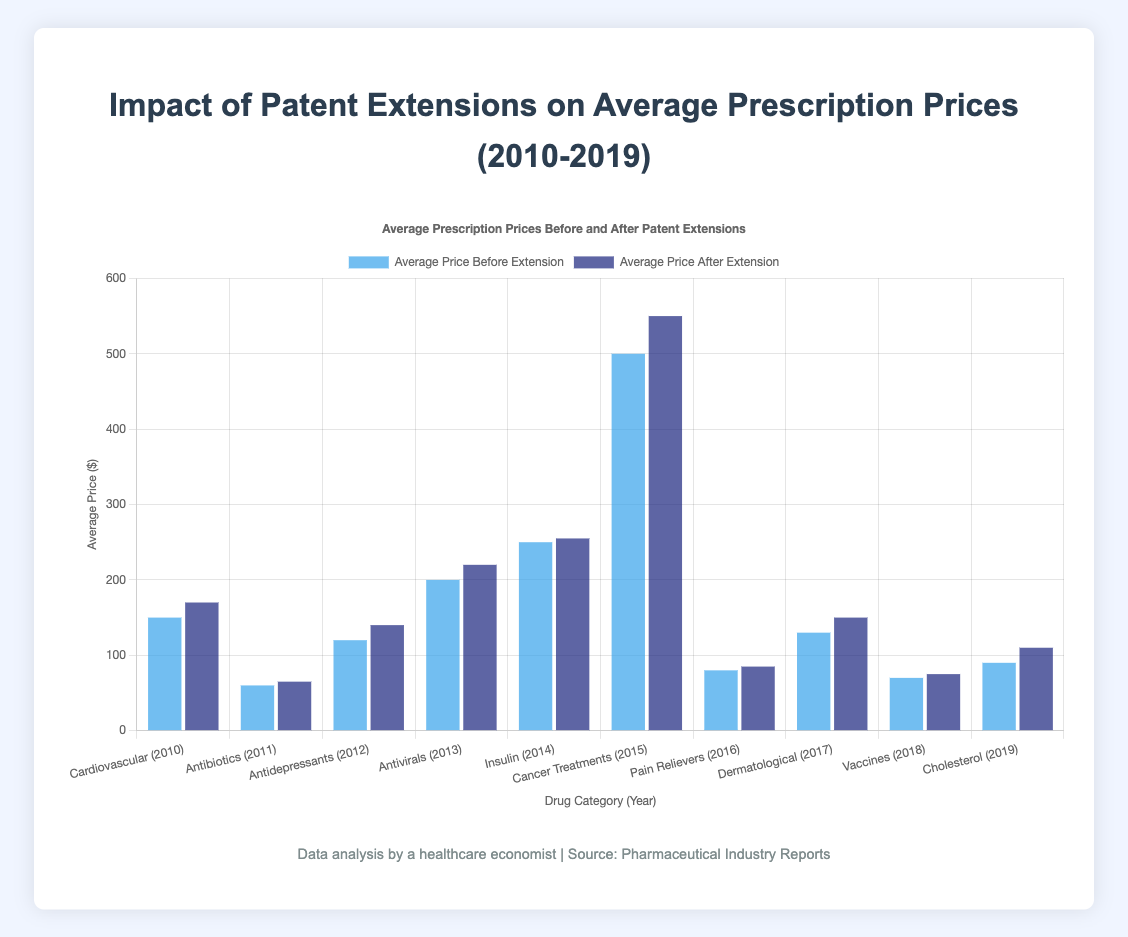What is the difference between the average price before and after the patent extension for Cardiovascular Medications? The average price before the extension is $150, and after the extension is $170. To find the difference, subtract 150 from 170: \(170 - 150 = 20\)
Answer: 20 Which year had the highest average prescription price after patent extensions, and what was the price? By looking at the bars representing prices after patent extensions, Cancer Treatments in 2015 had the highest with a price of $550.
Answer: 2015, $550 Was there any year when the average price after extension was equal to the average price before extension? By comparing the bars, no years had an equal average price before and after the extension.
Answer: No How much did the average price of Antivirals increase after the patent was extended? The average price before was $200, and after was $220. The increase is calculated by \(220 - 200 = 20\).
Answer: 20 Which category saw the smallest change in average price after the patent extension? By comparing the differences between the before and after bars, Insulin in 2014, with a difference of \(255 - 250 = 5\) shows the smallest change.
Answer: Insulin What is the combined average price after extension for the years 2015 and 2019? The average prices after extension for 2015 and 2019 are $550 and $110 respectively. Combined, this gives \(550 + 110 = 660\).
Answer: 660 Compare the average price increase after patent extension for Cancer Treatments and Dermatological Treatments. Which had a larger increase? Cancer Treatments in 2015 increased by \(550 - 500 = 50\) and Dermatological Treatments in 2017 increased by \(150 - 130 = 20\). Cancer Treatments had a larger increase.
Answer: Cancer Treatments How does the average price after extension for Vaccines compare to the average price before extension for Cardiovascular Medications? The average price after extension for Vaccines in 2018 is $75, while the average price before extension for Cardiovascular Medications in 2010 is $150. Vaccines' price after extension is less than that of Cardiovascular Medications before extension.
Answer: Less What was the average price increase for drugs with patent extensions across all years? Calculate the average increases for each year where the patent was extended: \((170-150)+(140-120)+(220-200)+(550-500)+(150-130)+(110-90))/6 = (20+20+20+50+20+20)/6 = 150/6 = 25\)
Answer: 25 What is the total average price before extension for all categories summed up? Sum the average prices before extension for all years: \(150+60+120+200+250+500+80+130+70+90 = 1650\)
Answer: 1650 